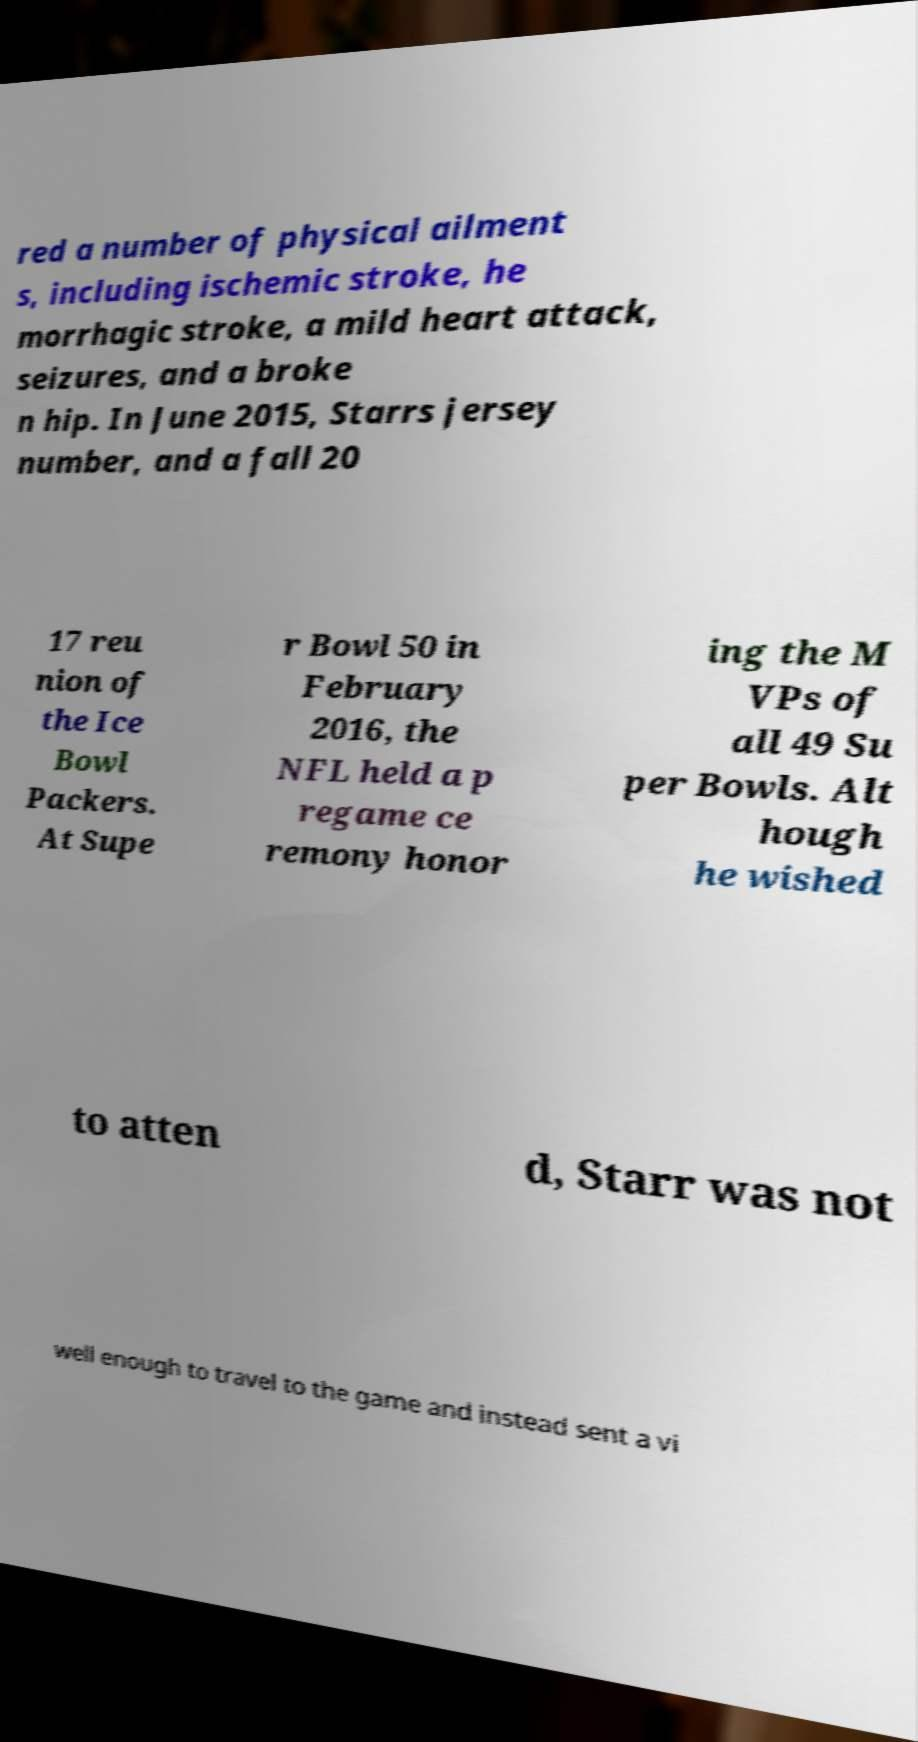Please read and relay the text visible in this image. What does it say? red a number of physical ailment s, including ischemic stroke, he morrhagic stroke, a mild heart attack, seizures, and a broke n hip. In June 2015, Starrs jersey number, and a fall 20 17 reu nion of the Ice Bowl Packers. At Supe r Bowl 50 in February 2016, the NFL held a p regame ce remony honor ing the M VPs of all 49 Su per Bowls. Alt hough he wished to atten d, Starr was not well enough to travel to the game and instead sent a vi 